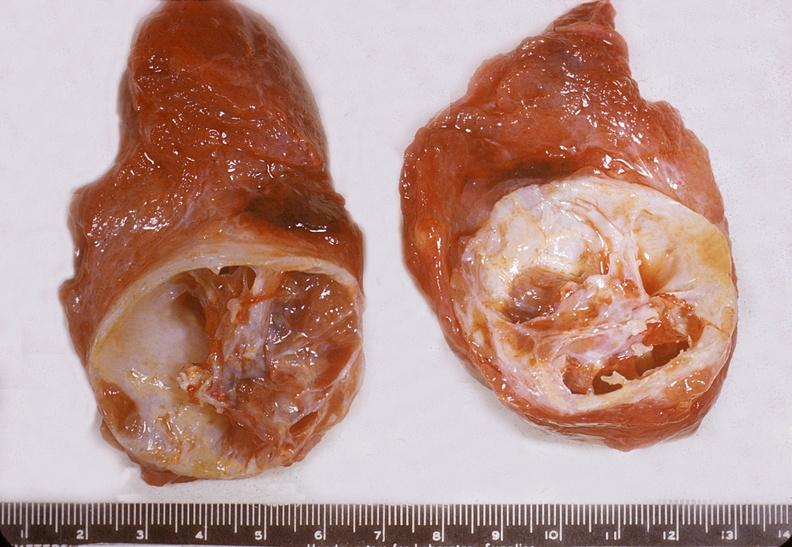does this image show thyroid, nodular colloid goiter with cystic degeneration?
Answer the question using a single word or phrase. Yes 